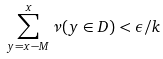<formula> <loc_0><loc_0><loc_500><loc_500>\sum _ { y = x - M } ^ { x } \nu ( y \in D ) < \epsilon / k</formula> 